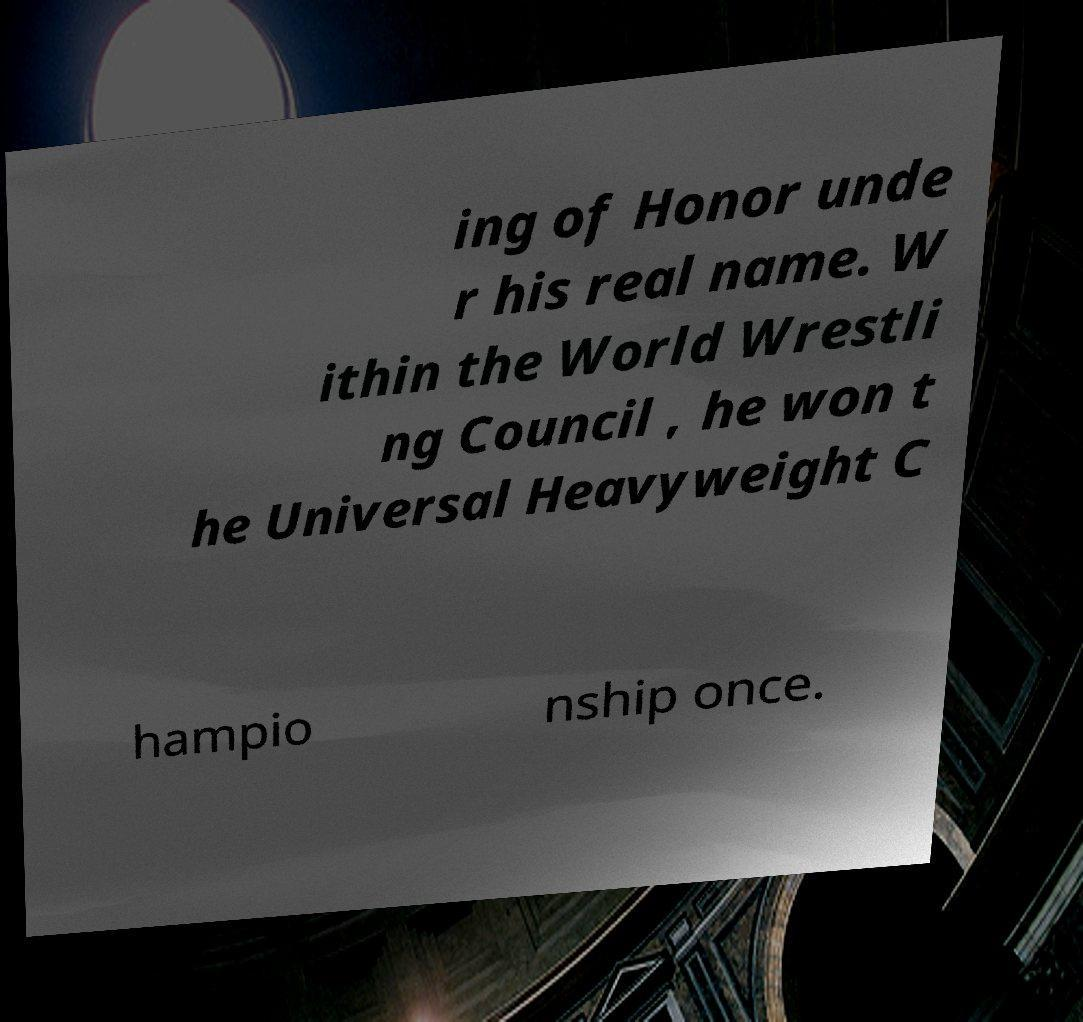What messages or text are displayed in this image? I need them in a readable, typed format. ing of Honor unde r his real name. W ithin the World Wrestli ng Council , he won t he Universal Heavyweight C hampio nship once. 